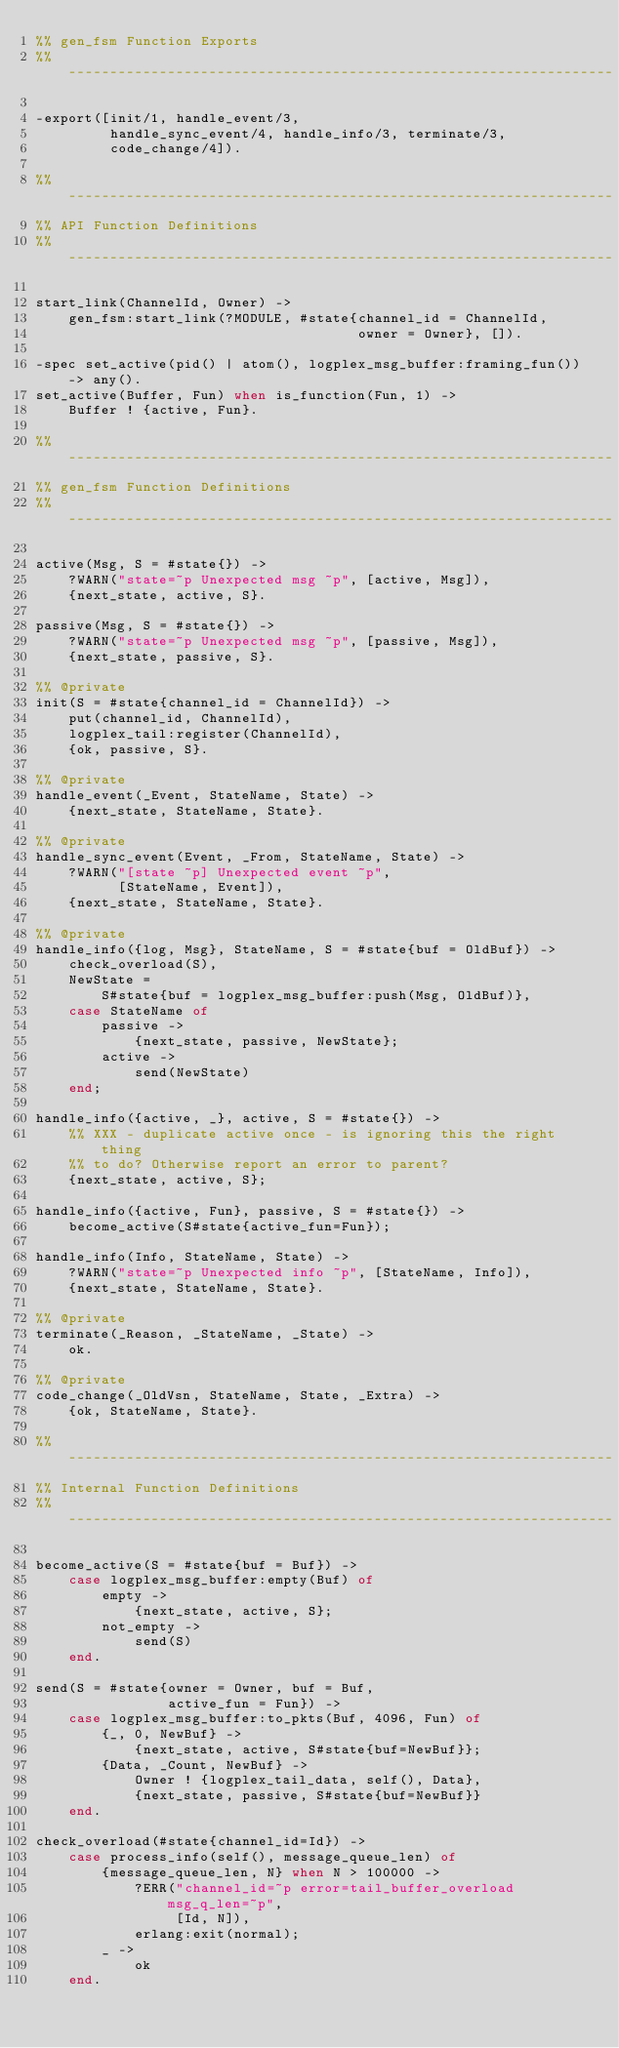<code> <loc_0><loc_0><loc_500><loc_500><_Erlang_>%% gen_fsm Function Exports
%% ------------------------------------------------------------------

-export([init/1, handle_event/3,
         handle_sync_event/4, handle_info/3, terminate/3,
         code_change/4]).

%% ------------------------------------------------------------------
%% API Function Definitions
%% ------------------------------------------------------------------

start_link(ChannelId, Owner) ->
    gen_fsm:start_link(?MODULE, #state{channel_id = ChannelId,
                                       owner = Owner}, []).

-spec set_active(pid() | atom(), logplex_msg_buffer:framing_fun()) -> any().
set_active(Buffer, Fun) when is_function(Fun, 1) ->
    Buffer ! {active, Fun}.

%% ------------------------------------------------------------------
%% gen_fsm Function Definitions
%% ------------------------------------------------------------------

active(Msg, S = #state{}) ->
    ?WARN("state=~p Unexpected msg ~p", [active, Msg]),
    {next_state, active, S}.

passive(Msg, S = #state{}) ->
    ?WARN("state=~p Unexpected msg ~p", [passive, Msg]),
    {next_state, passive, S}.

%% @private
init(S = #state{channel_id = ChannelId}) ->
    put(channel_id, ChannelId),
    logplex_tail:register(ChannelId),
    {ok, passive, S}.

%% @private
handle_event(_Event, StateName, State) ->
    {next_state, StateName, State}.

%% @private
handle_sync_event(Event, _From, StateName, State) ->
    ?WARN("[state ~p] Unexpected event ~p",
          [StateName, Event]),
    {next_state, StateName, State}.

%% @private
handle_info({log, Msg}, StateName, S = #state{buf = OldBuf}) ->
    check_overload(S),
    NewState =
        S#state{buf = logplex_msg_buffer:push(Msg, OldBuf)},
    case StateName of
        passive ->
            {next_state, passive, NewState};
        active ->
            send(NewState)
    end;

handle_info({active, _}, active, S = #state{}) ->
    %% XXX - duplicate active once - is ignoring this the right thing
    %% to do? Otherwise report an error to parent?
    {next_state, active, S};

handle_info({active, Fun}, passive, S = #state{}) ->
    become_active(S#state{active_fun=Fun});

handle_info(Info, StateName, State) ->
    ?WARN("state=~p Unexpected info ~p", [StateName, Info]),
    {next_state, StateName, State}.

%% @private
terminate(_Reason, _StateName, _State) ->
    ok.

%% @private
code_change(_OldVsn, StateName, State, _Extra) ->
    {ok, StateName, State}.

%% ------------------------------------------------------------------
%% Internal Function Definitions
%% ------------------------------------------------------------------

become_active(S = #state{buf = Buf}) ->
    case logplex_msg_buffer:empty(Buf) of
        empty ->
            {next_state, active, S};
        not_empty ->
            send(S)
    end.

send(S = #state{owner = Owner, buf = Buf,
                active_fun = Fun}) ->
    case logplex_msg_buffer:to_pkts(Buf, 4096, Fun) of
        {_, 0, NewBuf} ->
            {next_state, active, S#state{buf=NewBuf}};
        {Data, _Count, NewBuf} ->
            Owner ! {logplex_tail_data, self(), Data},
            {next_state, passive, S#state{buf=NewBuf}}
    end.

check_overload(#state{channel_id=Id}) ->
    case process_info(self(), message_queue_len) of
        {message_queue_len, N} when N > 100000 ->
            ?ERR("channel_id=~p error=tail_buffer_overload msg_q_len=~p",
                 [Id, N]),
            erlang:exit(normal);
        _ ->
            ok
    end.
</code> 